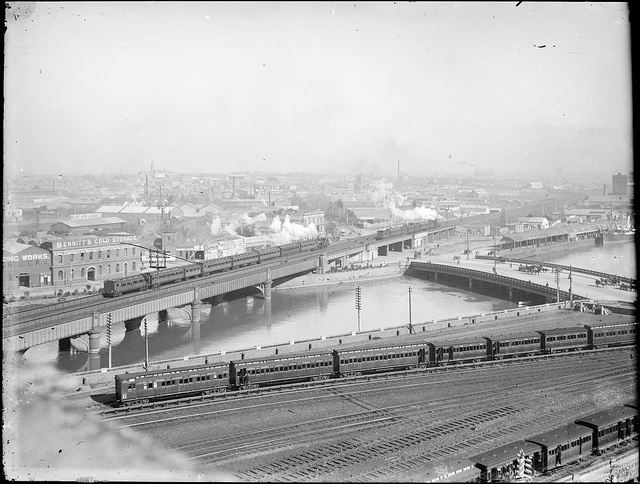Describe the objects in this image and their specific colors. I can see train in black, gray, darkgray, and lightgray tones, train in black, gray, darkgray, and lightgray tones, train in black, darkgray, gray, and lightgray tones, and train in darkgray, lightgray, gray, and black tones in this image. 